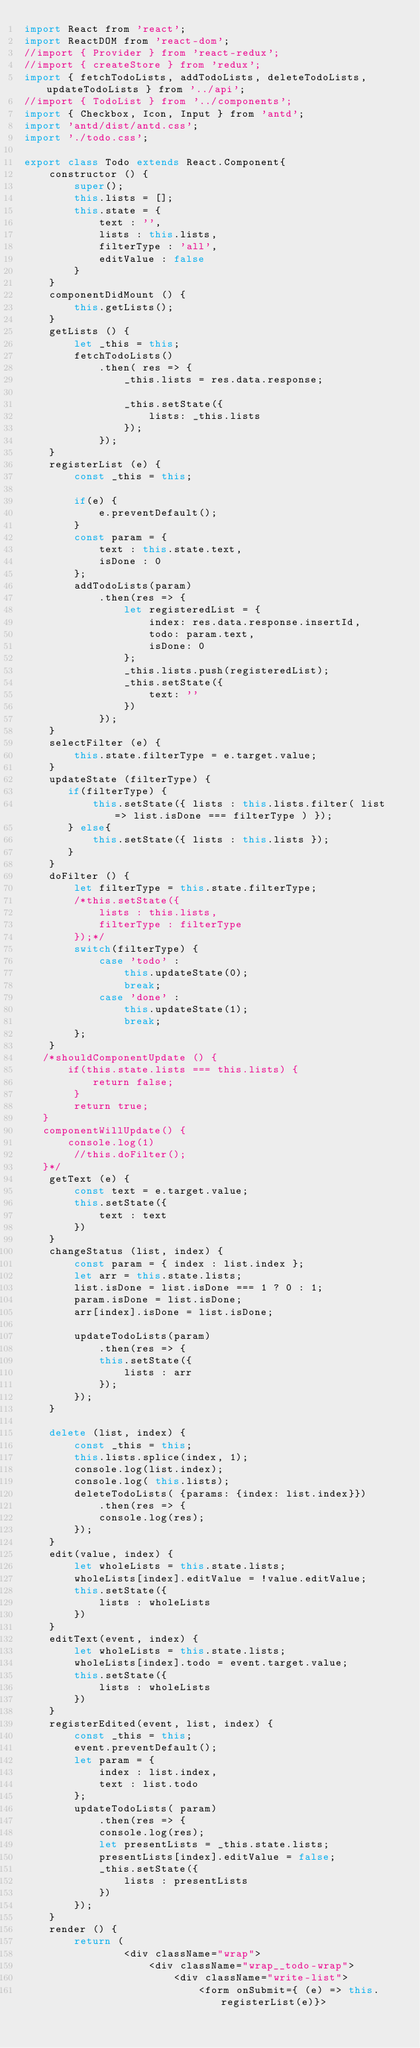Convert code to text. <code><loc_0><loc_0><loc_500><loc_500><_JavaScript_>import React from 'react';
import ReactDOM from 'react-dom';
//import { Provider } from 'react-redux';
//import { createStore } from 'redux';
import { fetchTodoLists, addTodoLists, deleteTodoLists, updateTodoLists } from '../api';
//import { TodoList } from '../components';
import { Checkbox, Icon, Input } from 'antd';
import 'antd/dist/antd.css';
import './todo.css';

export class Todo extends React.Component{
    constructor () {
        super();
        this.lists = [];
        this.state = {
            text : '',
            lists : this.lists,
            filterType : 'all',
            editValue : false
        }
    }
    componentDidMount () {
        this.getLists();
    }
    getLists () {
        let _this = this;
        fetchTodoLists()
            .then( res => {
                _this.lists = res.data.response;

                _this.setState({
                    lists: _this.lists
                });
            });
    }
    registerList (e) {
        const _this = this;

        if(e) {
            e.preventDefault();
        }
        const param = {
            text : this.state.text,
            isDone : 0
        };
        addTodoLists(param)
            .then(res => {
                let registeredList = {
                    index: res.data.response.insertId,
                    todo: param.text,
                    isDone: 0
                };
                _this.lists.push(registeredList);
                _this.setState({
                    text: ''
                })
            });
    }
	selectFilter (e) {
		this.state.filterType = e.target.value;
	}
    updateState (filterType) {
       if(filterType) {
           this.setState({ lists : this.lists.filter( list => list.isDone === filterType ) });
       } else{
           this.setState({ lists : this.lists });
       }
    }
    doFilter () {
        let filterType = this.state.filterType;
        /*this.setState({
            lists : this.lists,
            filterType : filterType
        });*/
        switch(filterType) {
            case 'todo' :
                this.updateState(0);
                break;
            case 'done' :
                this.updateState(1);
                break;
        };
    }
   /*shouldComponentUpdate () {
       if(this.state.lists === this.lists) {
           return false;
        }
        return true;
   }
   componentWillUpdate() {
       console.log(1)
        //this.doFilter();
   }*/
    getText (e) {
        const text = e.target.value;
        this.setState({
            text : text
        })
    }
    changeStatus (list, index) {
        const param = { index : list.index };
        let arr = this.state.lists;
        list.isDone = list.isDone === 1 ? 0 : 1;
        param.isDone = list.isDone;
        arr[index].isDone = list.isDone;

        updateTodoLists(param)
            .then(res => {
            this.setState({
                lists : arr
            });
        });
    }

    delete (list, index) {
        const _this = this;
        this.lists.splice(index, 1);
        console.log(list.index);
        console.log( this.lists);
        deleteTodoLists( {params: {index: list.index}})
            .then(res => {
            console.log(res);
        });
    }
    edit(value, index) {
        let wholeLists = this.state.lists;
        wholeLists[index].editValue = !value.editValue;
        this.setState({
            lists : wholeLists
        })
    }
    editText(event, index) {
        let wholeLists = this.state.lists;
        wholeLists[index].todo = event.target.value;
        this.setState({
            lists : wholeLists
        })
    }
    registerEdited(event, list, index) {
        const _this = this;
        event.preventDefault();
        let param = {
            index : list.index,
            text : list.todo
        };
        updateTodoLists( param)
            .then(res => {
            console.log(res);
            let presentLists = _this.state.lists;
            presentLists[index].editValue = false;
            _this.setState({
                lists : presentLists
            })
        });
    }
    render () {
        return (
                <div className="wrap">
                    <div className="wrap__todo-wrap">
                        <div className="write-list">
                            <form onSubmit={ (e) => this.registerList(e)}></code> 